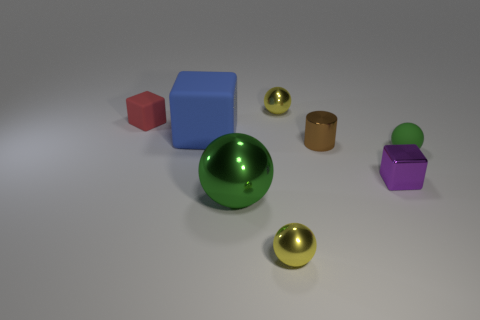What is the size of the matte object that is the same color as the big metallic ball?
Offer a very short reply. Small. There is another sphere that is the same color as the big sphere; what material is it?
Provide a succinct answer. Rubber. How many other red cubes have the same material as the large block?
Ensure brevity in your answer.  1. What shape is the shiny thing that is both to the left of the small brown thing and behind the tiny green thing?
Keep it short and to the point. Sphere. What number of things are either yellow shiny spheres in front of the small cylinder or yellow things that are behind the small green rubber object?
Your answer should be very brief. 2. Are there an equal number of yellow balls on the right side of the small green thing and green balls left of the tiny matte cube?
Offer a very short reply. Yes. There is a small yellow metallic object in front of the cube on the right side of the green shiny ball; what is its shape?
Provide a short and direct response. Sphere. Are there any brown objects of the same shape as the small red object?
Offer a terse response. No. How many matte objects are there?
Ensure brevity in your answer.  3. Are the small sphere that is right of the tiny metal cylinder and the small red thing made of the same material?
Your response must be concise. Yes. 